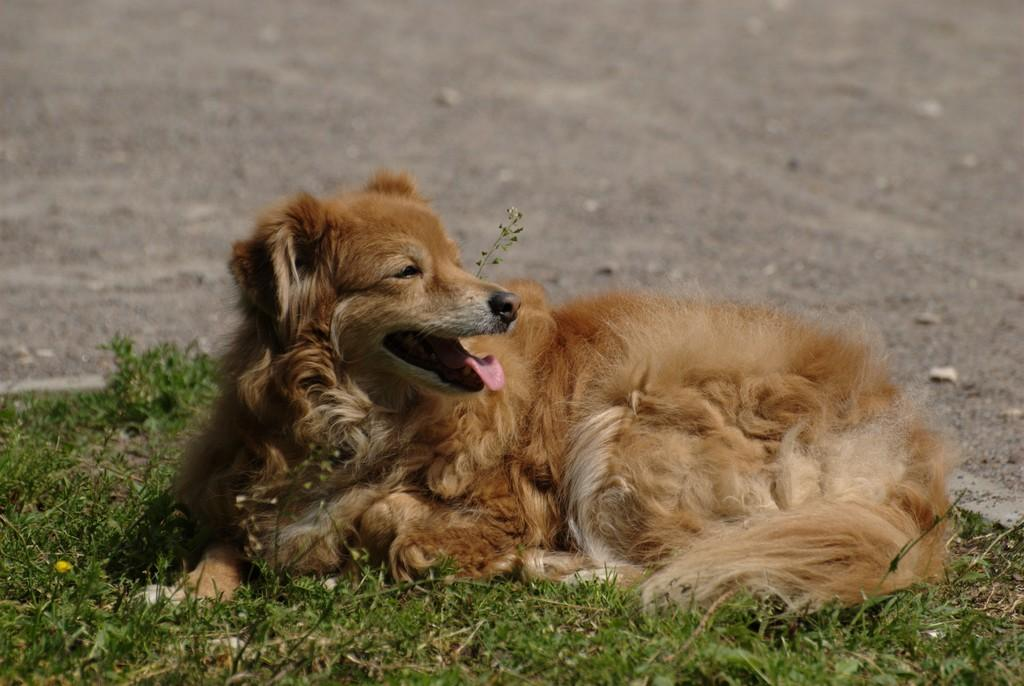What animal can be seen in the image? There is a dog in the image. Where is the dog located? The dog is sitting on grassland. What type of terrain is visible in the image? There is land visible at the top of the image. What type of skin condition does the dog have in the image? There is no indication of any skin condition on the dog in the image. What letters can be seen on the dog's collar in the image? There is no collar visible on the dog in the image. 